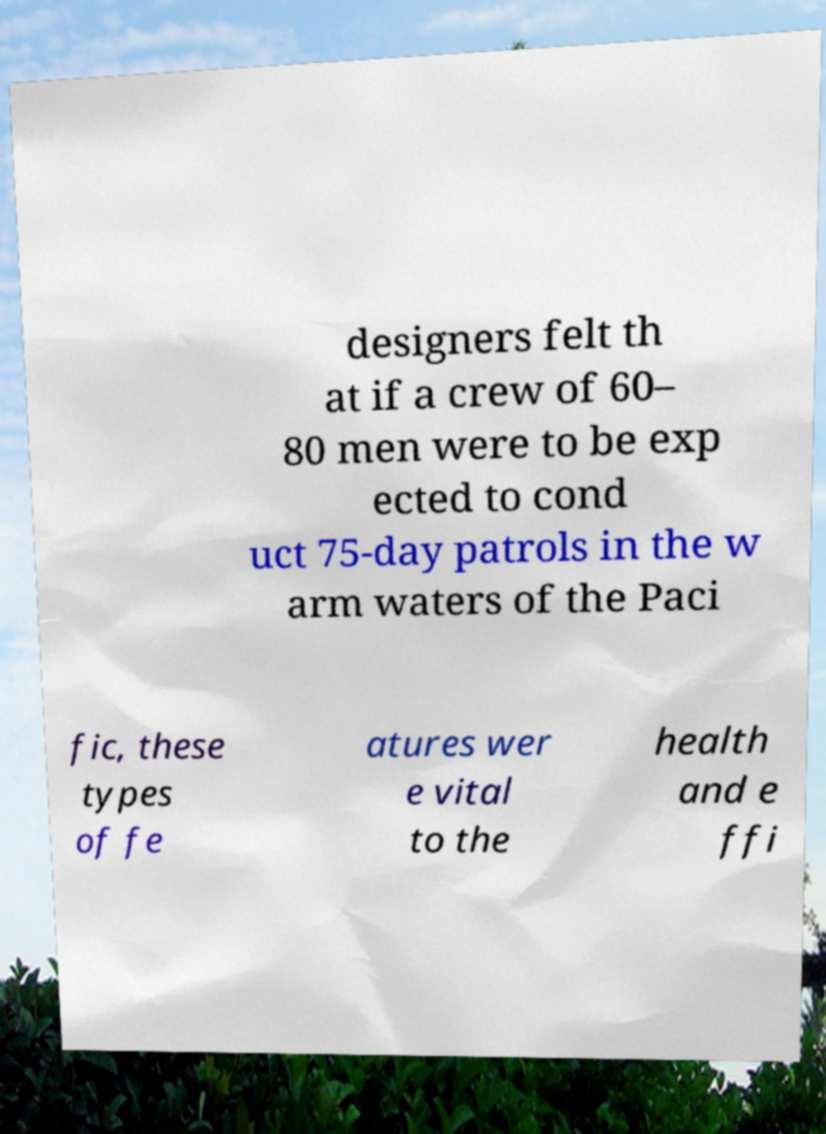I need the written content from this picture converted into text. Can you do that? designers felt th at if a crew of 60– 80 men were to be exp ected to cond uct 75-day patrols in the w arm waters of the Paci fic, these types of fe atures wer e vital to the health and e ffi 